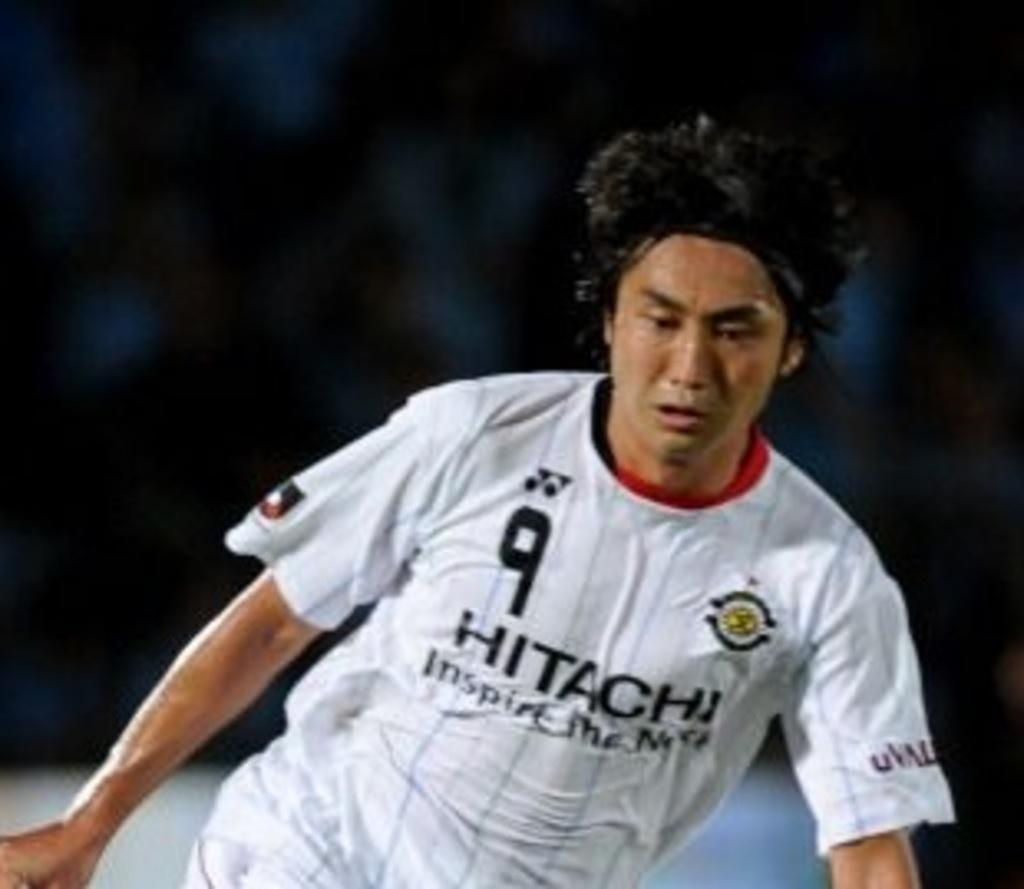<image>
Offer a succinct explanation of the picture presented. Man wearinga  white jersey that says HITACHI. 